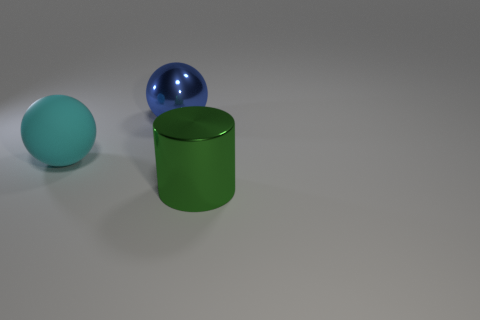Add 3 large metal balls. How many objects exist? 6 Subtract all cylinders. How many objects are left? 2 Subtract all metal cylinders. Subtract all large balls. How many objects are left? 0 Add 3 large rubber spheres. How many large rubber spheres are left? 4 Add 1 small cyan rubber objects. How many small cyan rubber objects exist? 1 Subtract 0 red cylinders. How many objects are left? 3 